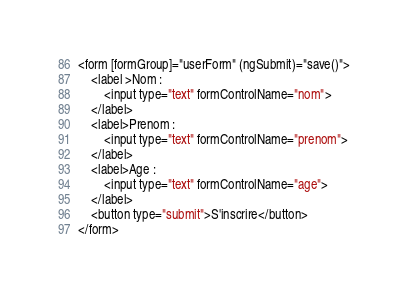<code> <loc_0><loc_0><loc_500><loc_500><_HTML_><form [formGroup]="userForm" (ngSubmit)="save()">
    <label >Nom :
        <input type="text" formControlName="nom">
    </label>
    <label>Prenom :
        <input type="text" formControlName="prenom">
    </label>
    <label>Age :
        <input type="text" formControlName="age">
    </label>   
    <button type="submit">S'inscrire</button>
</form></code> 